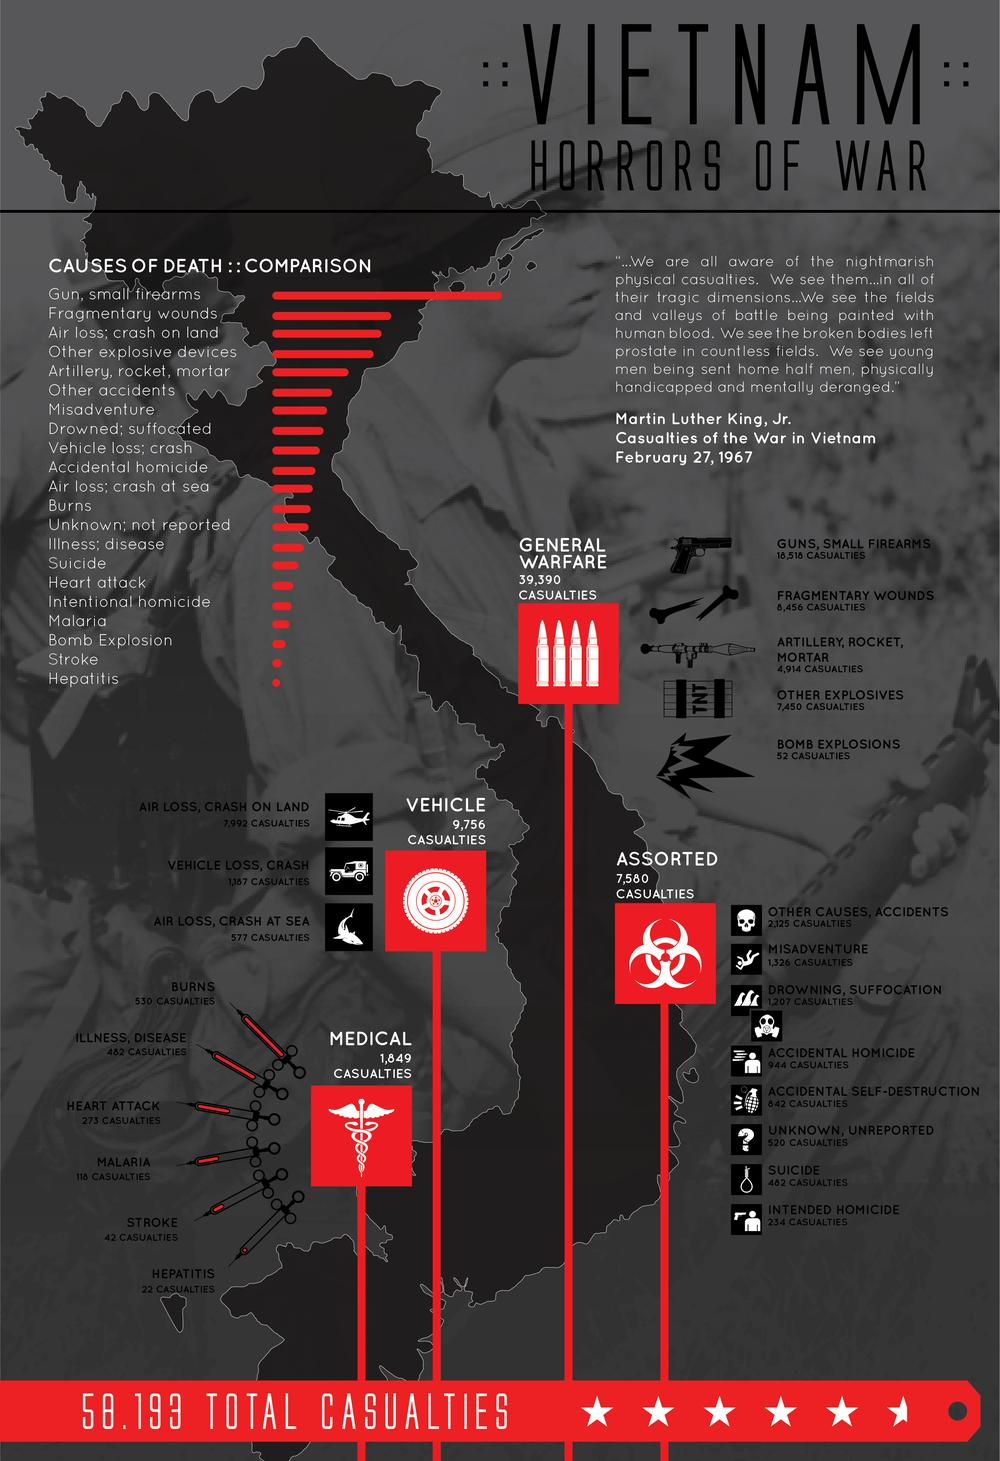Outline some significant characteristics in this image. There were 8,569 casualties in the flight crash on land and sea. There were 9,756 casualties in the vehicle. A total of 7,580 casualties were assorted. Bomb explosions are the third-least common cause of casualties in war, behind other forms of violence and disease. In the General Warfare, a total of 39,390 casualties were reported. 